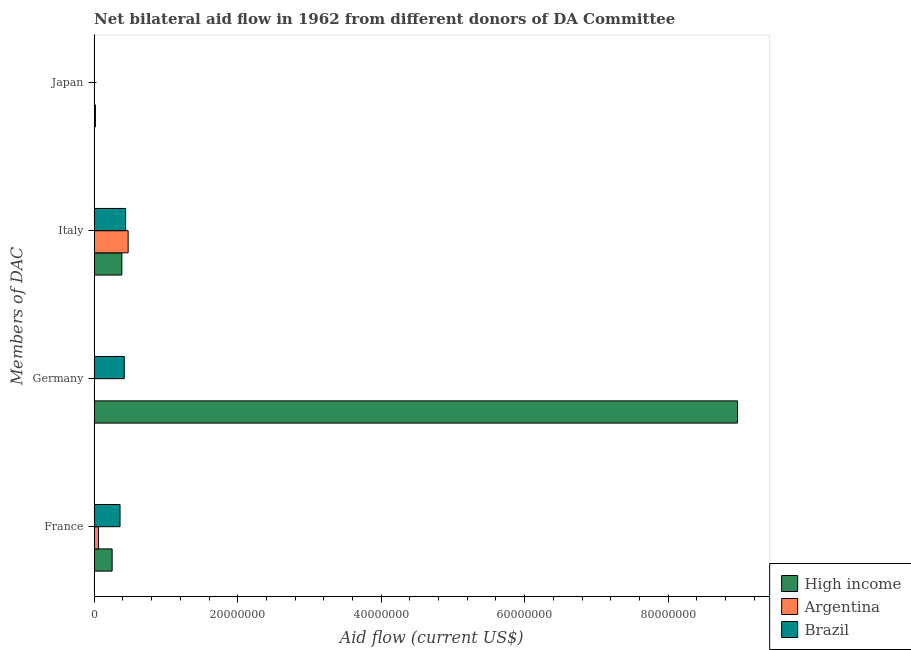How many different coloured bars are there?
Ensure brevity in your answer.  3. Are the number of bars per tick equal to the number of legend labels?
Ensure brevity in your answer.  No. What is the amount of aid given by germany in Brazil?
Provide a succinct answer. 4.19e+06. Across all countries, what is the maximum amount of aid given by france?
Your response must be concise. 3.60e+06. Across all countries, what is the minimum amount of aid given by italy?
Make the answer very short. 3.85e+06. What is the total amount of aid given by germany in the graph?
Give a very brief answer. 9.38e+07. What is the difference between the amount of aid given by france in High income and that in Brazil?
Give a very brief answer. -1.10e+06. What is the difference between the amount of aid given by japan in High income and the amount of aid given by italy in Brazil?
Give a very brief answer. -4.21e+06. What is the average amount of aid given by france per country?
Offer a very short reply. 2.23e+06. What is the difference between the amount of aid given by italy and amount of aid given by france in Brazil?
Offer a terse response. 7.80e+05. What is the ratio of the amount of aid given by france in Argentina to that in High income?
Offer a terse response. 0.24. What is the difference between the highest and the second highest amount of aid given by france?
Make the answer very short. 1.10e+06. What is the difference between the highest and the lowest amount of aid given by italy?
Your response must be concise. 8.80e+05. In how many countries, is the amount of aid given by germany greater than the average amount of aid given by germany taken over all countries?
Offer a terse response. 1. Is the sum of the amount of aid given by italy in High income and Argentina greater than the maximum amount of aid given by france across all countries?
Provide a short and direct response. Yes. Is it the case that in every country, the sum of the amount of aid given by germany and amount of aid given by italy is greater than the sum of amount of aid given by france and amount of aid given by japan?
Make the answer very short. Yes. Is it the case that in every country, the sum of the amount of aid given by france and amount of aid given by germany is greater than the amount of aid given by italy?
Offer a terse response. No. How many bars are there?
Make the answer very short. 9. How many countries are there in the graph?
Offer a very short reply. 3. Are the values on the major ticks of X-axis written in scientific E-notation?
Ensure brevity in your answer.  No. How many legend labels are there?
Your answer should be compact. 3. How are the legend labels stacked?
Your answer should be compact. Vertical. What is the title of the graph?
Make the answer very short. Net bilateral aid flow in 1962 from different donors of DA Committee. What is the label or title of the Y-axis?
Provide a short and direct response. Members of DAC. What is the Aid flow (current US$) in High income in France?
Your response must be concise. 2.50e+06. What is the Aid flow (current US$) in Brazil in France?
Keep it short and to the point. 3.60e+06. What is the Aid flow (current US$) of High income in Germany?
Ensure brevity in your answer.  8.97e+07. What is the Aid flow (current US$) of Argentina in Germany?
Provide a short and direct response. 0. What is the Aid flow (current US$) of Brazil in Germany?
Your answer should be compact. 4.19e+06. What is the Aid flow (current US$) in High income in Italy?
Your response must be concise. 3.85e+06. What is the Aid flow (current US$) in Argentina in Italy?
Provide a succinct answer. 4.73e+06. What is the Aid flow (current US$) in Brazil in Italy?
Provide a short and direct response. 4.38e+06. What is the Aid flow (current US$) of High income in Japan?
Make the answer very short. 1.70e+05. Across all Members of DAC, what is the maximum Aid flow (current US$) of High income?
Make the answer very short. 8.97e+07. Across all Members of DAC, what is the maximum Aid flow (current US$) of Argentina?
Offer a terse response. 4.73e+06. Across all Members of DAC, what is the maximum Aid flow (current US$) in Brazil?
Offer a terse response. 4.38e+06. Across all Members of DAC, what is the minimum Aid flow (current US$) of High income?
Keep it short and to the point. 1.70e+05. Across all Members of DAC, what is the minimum Aid flow (current US$) in Argentina?
Make the answer very short. 0. Across all Members of DAC, what is the minimum Aid flow (current US$) in Brazil?
Give a very brief answer. 0. What is the total Aid flow (current US$) of High income in the graph?
Give a very brief answer. 9.62e+07. What is the total Aid flow (current US$) of Argentina in the graph?
Offer a terse response. 5.33e+06. What is the total Aid flow (current US$) of Brazil in the graph?
Offer a very short reply. 1.22e+07. What is the difference between the Aid flow (current US$) of High income in France and that in Germany?
Make the answer very short. -8.72e+07. What is the difference between the Aid flow (current US$) in Brazil in France and that in Germany?
Offer a terse response. -5.90e+05. What is the difference between the Aid flow (current US$) of High income in France and that in Italy?
Offer a terse response. -1.35e+06. What is the difference between the Aid flow (current US$) of Argentina in France and that in Italy?
Offer a terse response. -4.13e+06. What is the difference between the Aid flow (current US$) of Brazil in France and that in Italy?
Keep it short and to the point. -7.80e+05. What is the difference between the Aid flow (current US$) of High income in France and that in Japan?
Offer a terse response. 2.33e+06. What is the difference between the Aid flow (current US$) in High income in Germany and that in Italy?
Ensure brevity in your answer.  8.58e+07. What is the difference between the Aid flow (current US$) of Brazil in Germany and that in Italy?
Provide a short and direct response. -1.90e+05. What is the difference between the Aid flow (current US$) in High income in Germany and that in Japan?
Your response must be concise. 8.95e+07. What is the difference between the Aid flow (current US$) of High income in Italy and that in Japan?
Offer a very short reply. 3.68e+06. What is the difference between the Aid flow (current US$) in High income in France and the Aid flow (current US$) in Brazil in Germany?
Your answer should be compact. -1.69e+06. What is the difference between the Aid flow (current US$) of Argentina in France and the Aid flow (current US$) of Brazil in Germany?
Ensure brevity in your answer.  -3.59e+06. What is the difference between the Aid flow (current US$) in High income in France and the Aid flow (current US$) in Argentina in Italy?
Give a very brief answer. -2.23e+06. What is the difference between the Aid flow (current US$) in High income in France and the Aid flow (current US$) in Brazil in Italy?
Your answer should be very brief. -1.88e+06. What is the difference between the Aid flow (current US$) of Argentina in France and the Aid flow (current US$) of Brazil in Italy?
Make the answer very short. -3.78e+06. What is the difference between the Aid flow (current US$) in High income in Germany and the Aid flow (current US$) in Argentina in Italy?
Keep it short and to the point. 8.49e+07. What is the difference between the Aid flow (current US$) in High income in Germany and the Aid flow (current US$) in Brazil in Italy?
Provide a succinct answer. 8.53e+07. What is the average Aid flow (current US$) of High income per Members of DAC?
Your answer should be compact. 2.40e+07. What is the average Aid flow (current US$) in Argentina per Members of DAC?
Keep it short and to the point. 1.33e+06. What is the average Aid flow (current US$) of Brazil per Members of DAC?
Make the answer very short. 3.04e+06. What is the difference between the Aid flow (current US$) of High income and Aid flow (current US$) of Argentina in France?
Your response must be concise. 1.90e+06. What is the difference between the Aid flow (current US$) in High income and Aid flow (current US$) in Brazil in France?
Your answer should be very brief. -1.10e+06. What is the difference between the Aid flow (current US$) in High income and Aid flow (current US$) in Brazil in Germany?
Your answer should be compact. 8.55e+07. What is the difference between the Aid flow (current US$) of High income and Aid flow (current US$) of Argentina in Italy?
Offer a terse response. -8.80e+05. What is the difference between the Aid flow (current US$) of High income and Aid flow (current US$) of Brazil in Italy?
Offer a terse response. -5.30e+05. What is the ratio of the Aid flow (current US$) of High income in France to that in Germany?
Make the answer very short. 0.03. What is the ratio of the Aid flow (current US$) in Brazil in France to that in Germany?
Your answer should be very brief. 0.86. What is the ratio of the Aid flow (current US$) in High income in France to that in Italy?
Keep it short and to the point. 0.65. What is the ratio of the Aid flow (current US$) of Argentina in France to that in Italy?
Your response must be concise. 0.13. What is the ratio of the Aid flow (current US$) of Brazil in France to that in Italy?
Your answer should be compact. 0.82. What is the ratio of the Aid flow (current US$) of High income in France to that in Japan?
Ensure brevity in your answer.  14.71. What is the ratio of the Aid flow (current US$) in High income in Germany to that in Italy?
Give a very brief answer. 23.29. What is the ratio of the Aid flow (current US$) in Brazil in Germany to that in Italy?
Provide a short and direct response. 0.96. What is the ratio of the Aid flow (current US$) in High income in Germany to that in Japan?
Provide a succinct answer. 527.41. What is the ratio of the Aid flow (current US$) of High income in Italy to that in Japan?
Keep it short and to the point. 22.65. What is the difference between the highest and the second highest Aid flow (current US$) in High income?
Provide a short and direct response. 8.58e+07. What is the difference between the highest and the second highest Aid flow (current US$) in Brazil?
Your answer should be compact. 1.90e+05. What is the difference between the highest and the lowest Aid flow (current US$) in High income?
Ensure brevity in your answer.  8.95e+07. What is the difference between the highest and the lowest Aid flow (current US$) in Argentina?
Your response must be concise. 4.73e+06. What is the difference between the highest and the lowest Aid flow (current US$) of Brazil?
Provide a succinct answer. 4.38e+06. 